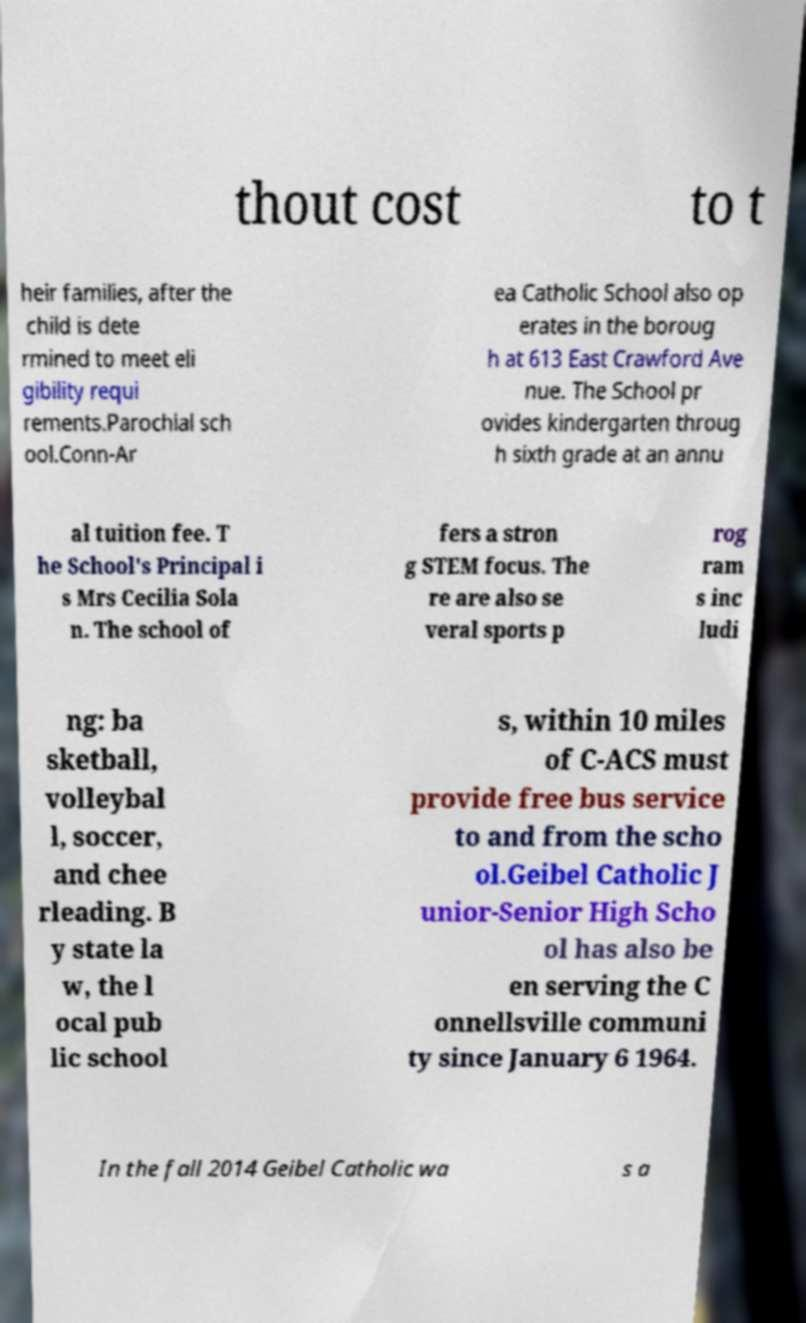Can you accurately transcribe the text from the provided image for me? thout cost to t heir families, after the child is dete rmined to meet eli gibility requi rements.Parochial sch ool.Conn-Ar ea Catholic School also op erates in the boroug h at 613 East Crawford Ave nue. The School pr ovides kindergarten throug h sixth grade at an annu al tuition fee. T he School's Principal i s Mrs Cecilia Sola n. The school of fers a stron g STEM focus. The re are also se veral sports p rog ram s inc ludi ng: ba sketball, volleybal l, soccer, and chee rleading. B y state la w, the l ocal pub lic school s, within 10 miles of C-ACS must provide free bus service to and from the scho ol.Geibel Catholic J unior-Senior High Scho ol has also be en serving the C onnellsville communi ty since January 6 1964. In the fall 2014 Geibel Catholic wa s a 